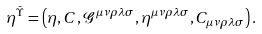Convert formula to latex. <formula><loc_0><loc_0><loc_500><loc_500>\eta ^ { \bar { \Upsilon } } = \left ( \eta , C , \mathcal { G } ^ { \mu \nu \rho \lambda \sigma } , \eta ^ { \mu \nu \rho \lambda \sigma } , C _ { \mu \nu \rho \lambda \sigma } \right ) .</formula> 